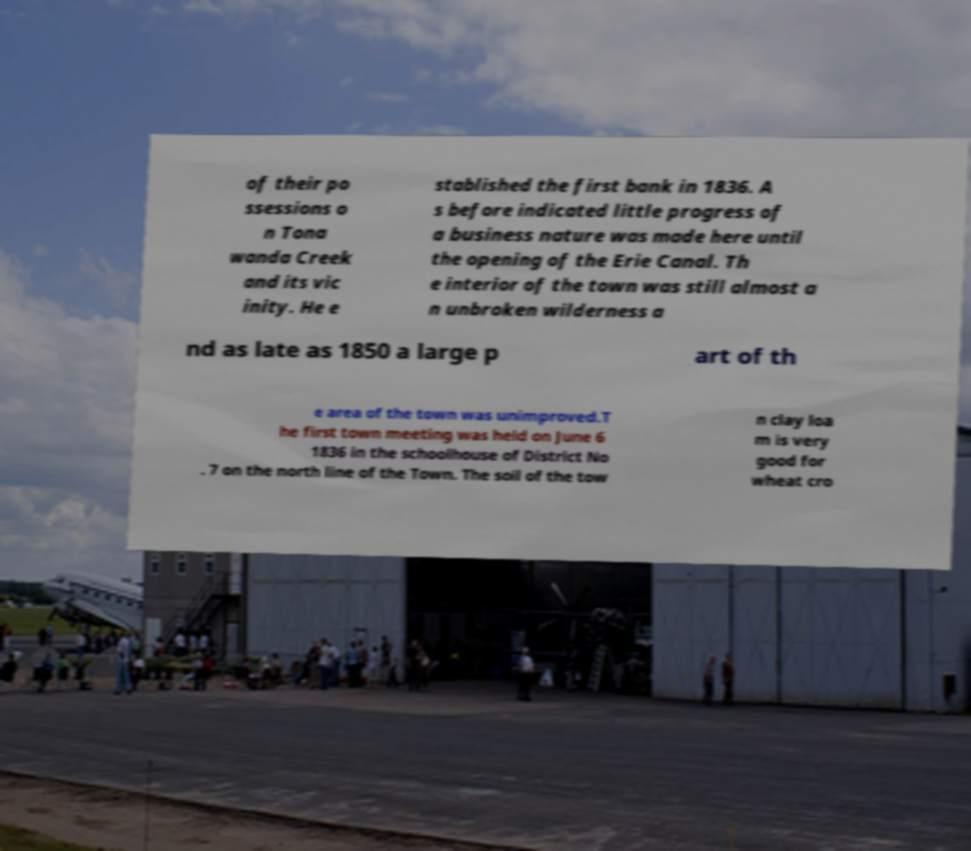Could you extract and type out the text from this image? of their po ssessions o n Tona wanda Creek and its vic inity. He e stablished the first bank in 1836. A s before indicated little progress of a business nature was made here until the opening of the Erie Canal. Th e interior of the town was still almost a n unbroken wilderness a nd as late as 1850 a large p art of th e area of the town was unimproved.T he first town meeting was held on June 6 1836 in the schoolhouse of District No . 7 on the north line of the Town. The soil of the tow n clay loa m is very good for wheat cro 